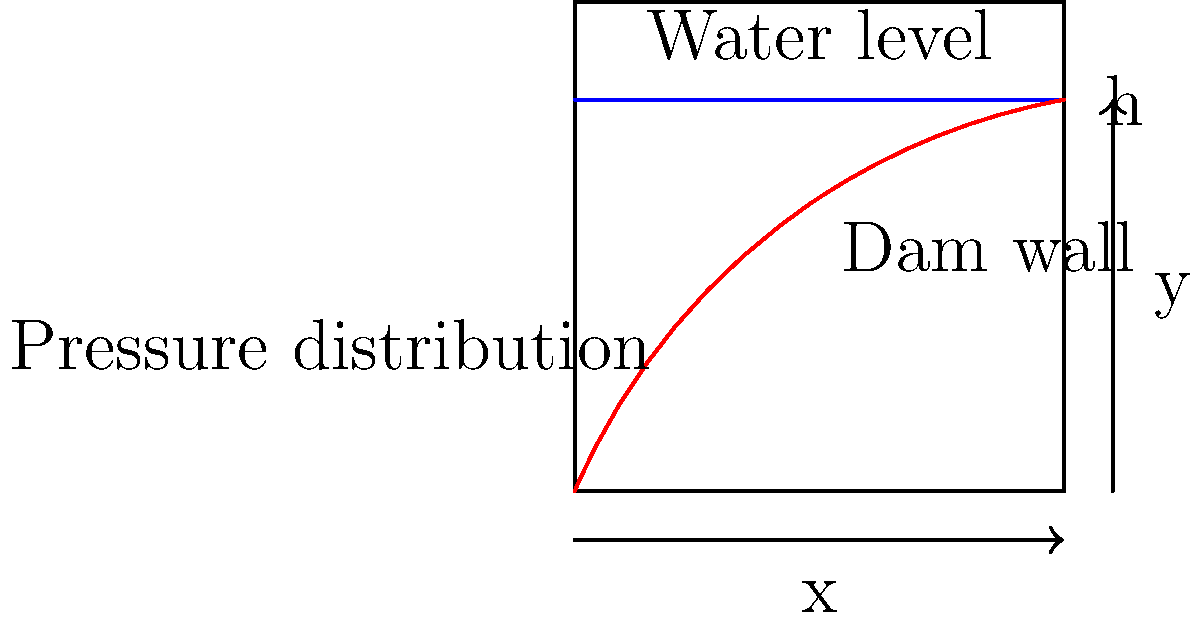In the context of ancient hydraulic systems, consider a dam wall with a height of $h$ meters and a reservoir filled to the top. Describe the shape of the water pressure distribution on the dam wall and explain why this distribution is crucial for analyzing the structural integrity of ancient dam constructions. To understand the water pressure distribution on a dam wall, we need to consider the following steps:

1. Hydrostatic pressure principle: The pressure at any point in a fluid at rest is directly proportional to the depth of that point below the fluid surface.

2. Pressure equation: The hydrostatic pressure at a depth $y$ is given by:
   $$P = \rho g y$$
   where $\rho$ is the density of water, $g$ is the acceleration due to gravity, and $y$ is the depth from the water surface.

3. Pressure distribution: As the depth increases linearly from the water surface to the bottom of the dam, the pressure also increases linearly. This creates a triangular pressure distribution.

4. Shape of the distribution: The pressure distribution forms a right-angled triangle with:
   - Zero pressure at the water surface (y = h)
   - Maximum pressure at the bottom of the dam (y = 0)
   - A linear increase in between

5. Maximum pressure: The maximum pressure at the bottom of the dam is:
   $$P_{max} = \rho g h$$

6. Resultant force: The total force on the dam is represented by the area of the triangular pressure distribution.

7. Importance for ancient structures: Understanding this pressure distribution is crucial for analyzing ancient dam constructions because:
   - It determines the minimum thickness required for the dam wall to withstand the water pressure.
   - It helps in identifying potential weak points in the structure.
   - It guides the design of buttresses or other supporting structures.
   - It aids in understanding how ancient engineers might have empirically designed their dams to withstand these forces.

This analysis allows linguists and archaeologists to better interpret ancient texts or inscriptions related to dam construction and water management systems.
Answer: Triangular distribution with maximum pressure at the bottom, crucial for structural analysis of ancient dams. 